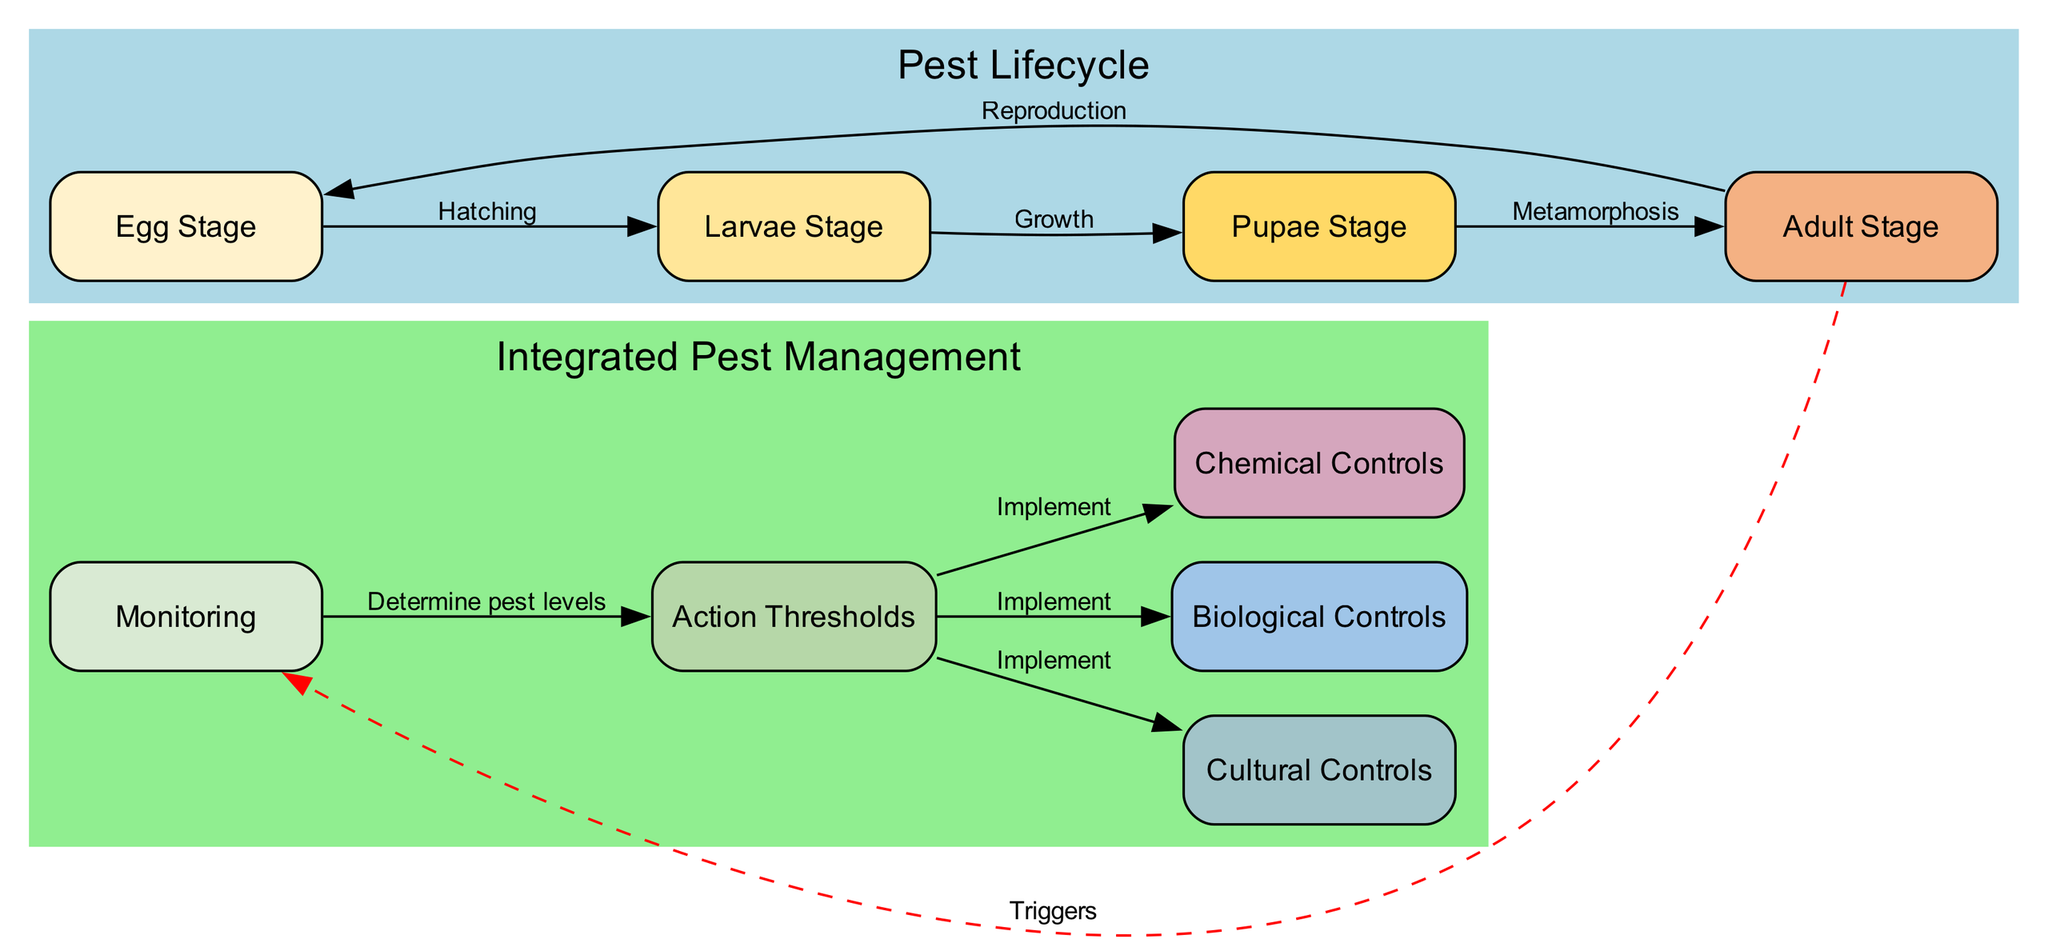What is the first stage in the pest lifecycle? The diagram indicates the first stage is labeled "Egg Stage." This is where pests lay eggs before hatching.
Answer: Egg Stage How many main stages are in the pest lifecycle? By counting the nodes related to the lifecycle, there are four stages: Egg Stage, Larvae Stage, Pupae Stage, and Adult Stage.
Answer: Four What does the transition from the Larvae Stage to the Pupae Stage represent? The edge connecting these two stages is labeled "Growth and development," indicating that this transition signifies a critical period of growth for the pests.
Answer: Growth and development Which control method is implemented after determining action thresholds? The edges labeled "Implement controls" from the Action Thresholds node connect to three control methods: Cultural Controls, Biological Controls, and Chemical Controls, indicating that these methods are applied after evaluating pest levels.
Answer: Cultural Controls, Biological Controls, Chemical Controls What triggers the monitoring stage in the pest management section? The diagram shows a dashed line from the Adult Stage to the Monitoring node, labeled "Triggers." This indicates that observing adult pests prompts the monitoring actions.
Answer: Adult Stage How does pest monitoring relate to action thresholds? The edge labeled "Determine pest levels" links Monitoring to Action Thresholds, depicting that monitoring pest levels helps to inform when action should be taken based on pest activity.
Answer: Determine pest levels What is the last stage before pests return to the Egg Stage? The diagram illustrates that the last stage prior to returning to the Egg Stage is labeled "Adult Stage," highlighting that adults, after reproduction, cycle back to the beginning of the lifecycle.
Answer: Adult Stage Which pest management strategy involves natural predators? The diagram specifies "Biological Controls" as the strategy that utilizes natural predators or pathogens to manage pest populations.
Answer: Biological Controls What color is used to signify the Pupae Stage in the diagram? The diagram denotes the Pupae Stage with a yellow color fill, differentiating it visually from other stages.
Answer: Yellow 